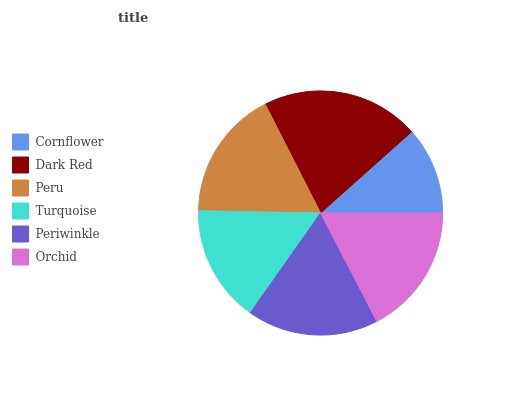Is Cornflower the minimum?
Answer yes or no. Yes. Is Dark Red the maximum?
Answer yes or no. Yes. Is Peru the minimum?
Answer yes or no. No. Is Peru the maximum?
Answer yes or no. No. Is Dark Red greater than Peru?
Answer yes or no. Yes. Is Peru less than Dark Red?
Answer yes or no. Yes. Is Peru greater than Dark Red?
Answer yes or no. No. Is Dark Red less than Peru?
Answer yes or no. No. Is Orchid the high median?
Answer yes or no. Yes. Is Peru the low median?
Answer yes or no. Yes. Is Dark Red the high median?
Answer yes or no. No. Is Orchid the low median?
Answer yes or no. No. 